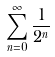Convert formula to latex. <formula><loc_0><loc_0><loc_500><loc_500>\sum _ { n = 0 } ^ { \infty } \frac { 1 } { 2 ^ { n } }</formula> 